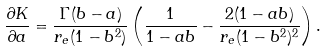<formula> <loc_0><loc_0><loc_500><loc_500>\frac { \partial K } { \partial a } = \frac { \Gamma ( b - a ) } { r _ { e } ( 1 - b ^ { 2 } ) } \left ( \frac { 1 } { 1 - a b } - \frac { 2 ( 1 - a b ) } { r _ { e } ( 1 - b ^ { 2 } ) ^ { 2 } } \right ) .</formula> 